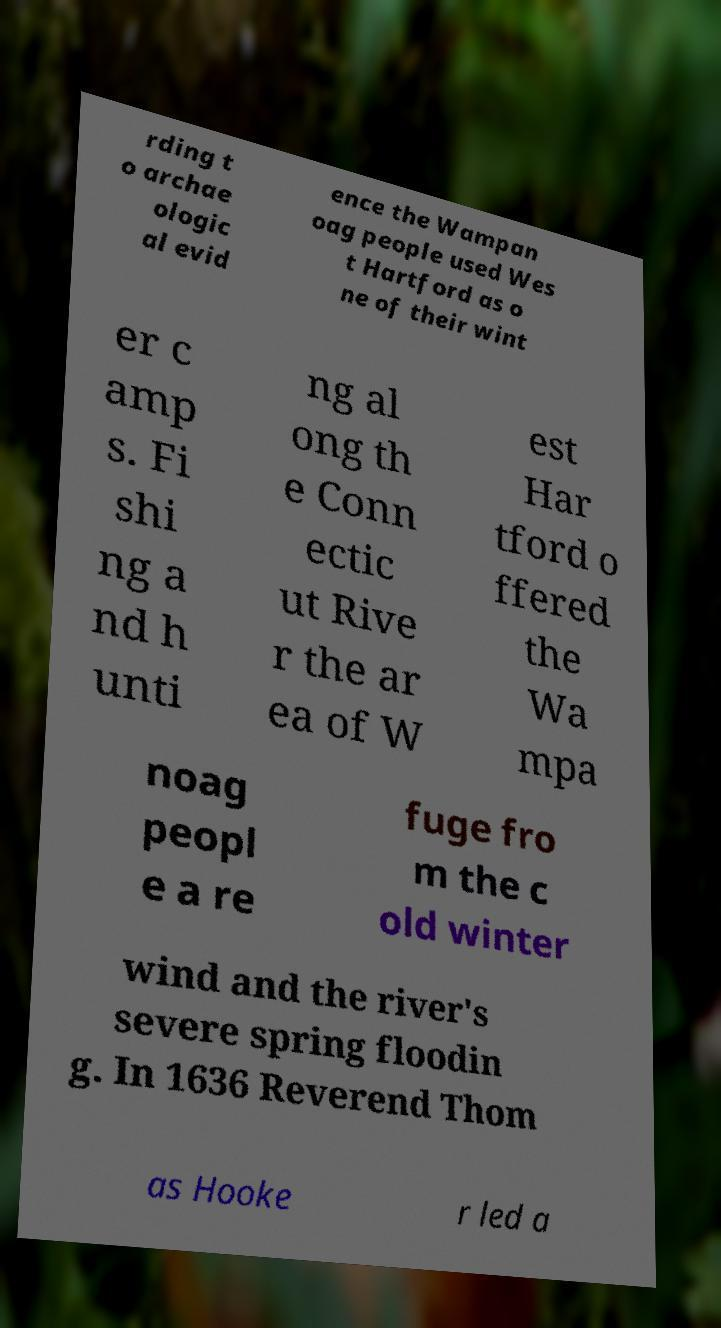Could you extract and type out the text from this image? rding t o archae ologic al evid ence the Wampan oag people used Wes t Hartford as o ne of their wint er c amp s. Fi shi ng a nd h unti ng al ong th e Conn ectic ut Rive r the ar ea of W est Har tford o ffered the Wa mpa noag peopl e a re fuge fro m the c old winter wind and the river's severe spring floodin g. In 1636 Reverend Thom as Hooke r led a 